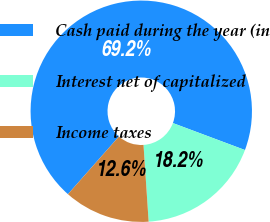<chart> <loc_0><loc_0><loc_500><loc_500><pie_chart><fcel>Cash paid during the year (in<fcel>Interest net of capitalized<fcel>Income taxes<nl><fcel>69.17%<fcel>18.24%<fcel>12.58%<nl></chart> 